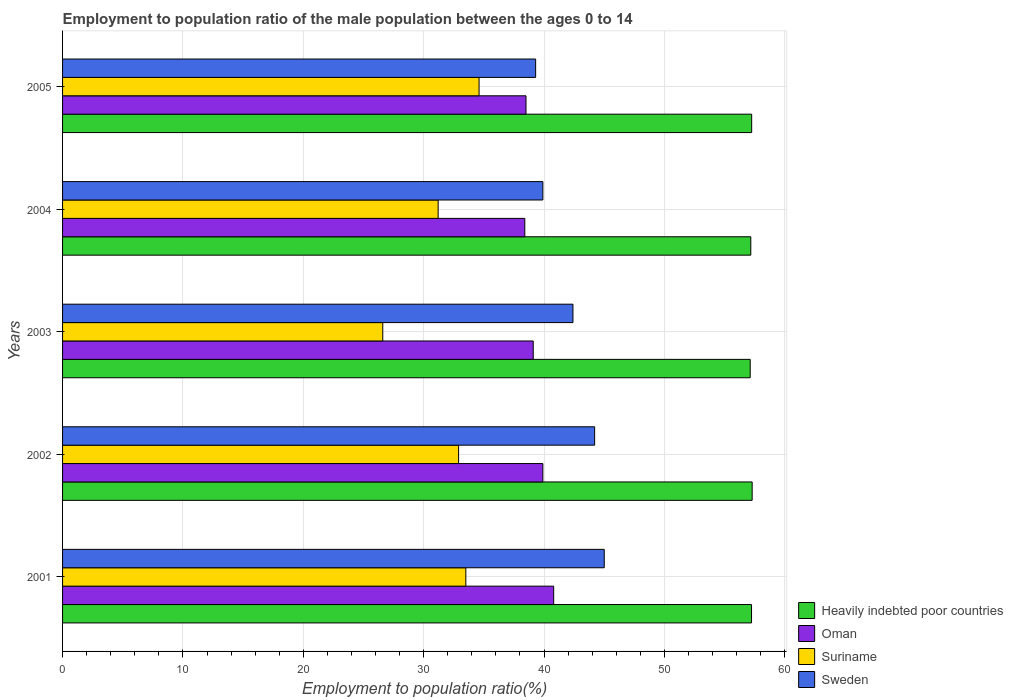How many groups of bars are there?
Keep it short and to the point. 5. Are the number of bars per tick equal to the number of legend labels?
Give a very brief answer. Yes. How many bars are there on the 4th tick from the top?
Make the answer very short. 4. How many bars are there on the 2nd tick from the bottom?
Provide a short and direct response. 4. What is the label of the 4th group of bars from the top?
Ensure brevity in your answer.  2002. What is the employment to population ratio in Sweden in 2004?
Your answer should be compact. 39.9. Across all years, what is the maximum employment to population ratio in Heavily indebted poor countries?
Your answer should be compact. 57.29. Across all years, what is the minimum employment to population ratio in Sweden?
Keep it short and to the point. 39.3. In which year was the employment to population ratio in Heavily indebted poor countries maximum?
Your answer should be compact. 2002. In which year was the employment to population ratio in Sweden minimum?
Make the answer very short. 2005. What is the total employment to population ratio in Sweden in the graph?
Provide a succinct answer. 210.8. What is the difference between the employment to population ratio in Suriname in 2003 and that in 2004?
Your answer should be compact. -4.6. What is the difference between the employment to population ratio in Oman in 2005 and the employment to population ratio in Heavily indebted poor countries in 2002?
Your answer should be very brief. -18.79. What is the average employment to population ratio in Oman per year?
Keep it short and to the point. 39.34. In the year 2003, what is the difference between the employment to population ratio in Heavily indebted poor countries and employment to population ratio in Oman?
Your response must be concise. 18.02. What is the ratio of the employment to population ratio in Suriname in 2003 to that in 2004?
Provide a succinct answer. 0.85. What is the difference between the highest and the second highest employment to population ratio in Sweden?
Keep it short and to the point. 0.8. What is the difference between the highest and the lowest employment to population ratio in Oman?
Provide a succinct answer. 2.4. In how many years, is the employment to population ratio in Sweden greater than the average employment to population ratio in Sweden taken over all years?
Offer a terse response. 3. Is the sum of the employment to population ratio in Suriname in 2004 and 2005 greater than the maximum employment to population ratio in Heavily indebted poor countries across all years?
Your answer should be very brief. Yes. Is it the case that in every year, the sum of the employment to population ratio in Suriname and employment to population ratio in Oman is greater than the sum of employment to population ratio in Sweden and employment to population ratio in Heavily indebted poor countries?
Make the answer very short. No. What does the 2nd bar from the top in 2002 represents?
Your answer should be very brief. Suriname. How many bars are there?
Give a very brief answer. 20. Are all the bars in the graph horizontal?
Your answer should be compact. Yes. What is the difference between two consecutive major ticks on the X-axis?
Your answer should be compact. 10. Are the values on the major ticks of X-axis written in scientific E-notation?
Your answer should be compact. No. Does the graph contain any zero values?
Your response must be concise. No. Where does the legend appear in the graph?
Provide a short and direct response. Bottom right. What is the title of the graph?
Your answer should be very brief. Employment to population ratio of the male population between the ages 0 to 14. Does "Guyana" appear as one of the legend labels in the graph?
Provide a succinct answer. No. What is the Employment to population ratio(%) of Heavily indebted poor countries in 2001?
Ensure brevity in your answer.  57.24. What is the Employment to population ratio(%) in Oman in 2001?
Your response must be concise. 40.8. What is the Employment to population ratio(%) of Suriname in 2001?
Keep it short and to the point. 33.5. What is the Employment to population ratio(%) of Sweden in 2001?
Ensure brevity in your answer.  45. What is the Employment to population ratio(%) of Heavily indebted poor countries in 2002?
Offer a terse response. 57.29. What is the Employment to population ratio(%) of Oman in 2002?
Your answer should be very brief. 39.9. What is the Employment to population ratio(%) in Suriname in 2002?
Offer a very short reply. 32.9. What is the Employment to population ratio(%) in Sweden in 2002?
Your response must be concise. 44.2. What is the Employment to population ratio(%) of Heavily indebted poor countries in 2003?
Provide a short and direct response. 57.12. What is the Employment to population ratio(%) of Oman in 2003?
Keep it short and to the point. 39.1. What is the Employment to population ratio(%) in Suriname in 2003?
Keep it short and to the point. 26.6. What is the Employment to population ratio(%) of Sweden in 2003?
Your response must be concise. 42.4. What is the Employment to population ratio(%) in Heavily indebted poor countries in 2004?
Ensure brevity in your answer.  57.17. What is the Employment to population ratio(%) of Oman in 2004?
Your answer should be very brief. 38.4. What is the Employment to population ratio(%) in Suriname in 2004?
Your answer should be very brief. 31.2. What is the Employment to population ratio(%) in Sweden in 2004?
Give a very brief answer. 39.9. What is the Employment to population ratio(%) of Heavily indebted poor countries in 2005?
Provide a succinct answer. 57.25. What is the Employment to population ratio(%) in Oman in 2005?
Give a very brief answer. 38.5. What is the Employment to population ratio(%) in Suriname in 2005?
Give a very brief answer. 34.6. What is the Employment to population ratio(%) of Sweden in 2005?
Keep it short and to the point. 39.3. Across all years, what is the maximum Employment to population ratio(%) of Heavily indebted poor countries?
Make the answer very short. 57.29. Across all years, what is the maximum Employment to population ratio(%) of Oman?
Your answer should be very brief. 40.8. Across all years, what is the maximum Employment to population ratio(%) in Suriname?
Your response must be concise. 34.6. Across all years, what is the maximum Employment to population ratio(%) in Sweden?
Your response must be concise. 45. Across all years, what is the minimum Employment to population ratio(%) of Heavily indebted poor countries?
Ensure brevity in your answer.  57.12. Across all years, what is the minimum Employment to population ratio(%) of Oman?
Offer a very short reply. 38.4. Across all years, what is the minimum Employment to population ratio(%) of Suriname?
Your answer should be very brief. 26.6. Across all years, what is the minimum Employment to population ratio(%) of Sweden?
Provide a short and direct response. 39.3. What is the total Employment to population ratio(%) of Heavily indebted poor countries in the graph?
Provide a succinct answer. 286.07. What is the total Employment to population ratio(%) in Oman in the graph?
Ensure brevity in your answer.  196.7. What is the total Employment to population ratio(%) in Suriname in the graph?
Your answer should be very brief. 158.8. What is the total Employment to population ratio(%) in Sweden in the graph?
Provide a short and direct response. 210.8. What is the difference between the Employment to population ratio(%) of Heavily indebted poor countries in 2001 and that in 2002?
Provide a succinct answer. -0.05. What is the difference between the Employment to population ratio(%) in Oman in 2001 and that in 2002?
Give a very brief answer. 0.9. What is the difference between the Employment to population ratio(%) in Suriname in 2001 and that in 2002?
Keep it short and to the point. 0.6. What is the difference between the Employment to population ratio(%) of Heavily indebted poor countries in 2001 and that in 2003?
Your answer should be compact. 0.11. What is the difference between the Employment to population ratio(%) in Oman in 2001 and that in 2003?
Your answer should be very brief. 1.7. What is the difference between the Employment to population ratio(%) of Suriname in 2001 and that in 2003?
Your answer should be very brief. 6.9. What is the difference between the Employment to population ratio(%) in Sweden in 2001 and that in 2003?
Keep it short and to the point. 2.6. What is the difference between the Employment to population ratio(%) in Heavily indebted poor countries in 2001 and that in 2004?
Provide a short and direct response. 0.06. What is the difference between the Employment to population ratio(%) in Oman in 2001 and that in 2004?
Ensure brevity in your answer.  2.4. What is the difference between the Employment to population ratio(%) in Sweden in 2001 and that in 2004?
Ensure brevity in your answer.  5.1. What is the difference between the Employment to population ratio(%) of Heavily indebted poor countries in 2001 and that in 2005?
Ensure brevity in your answer.  -0.01. What is the difference between the Employment to population ratio(%) of Oman in 2001 and that in 2005?
Offer a very short reply. 2.3. What is the difference between the Employment to population ratio(%) in Sweden in 2001 and that in 2005?
Your answer should be very brief. 5.7. What is the difference between the Employment to population ratio(%) of Heavily indebted poor countries in 2002 and that in 2003?
Your answer should be very brief. 0.16. What is the difference between the Employment to population ratio(%) in Oman in 2002 and that in 2003?
Make the answer very short. 0.8. What is the difference between the Employment to population ratio(%) of Heavily indebted poor countries in 2002 and that in 2004?
Provide a short and direct response. 0.11. What is the difference between the Employment to population ratio(%) in Sweden in 2002 and that in 2004?
Offer a very short reply. 4.3. What is the difference between the Employment to population ratio(%) of Heavily indebted poor countries in 2002 and that in 2005?
Give a very brief answer. 0.04. What is the difference between the Employment to population ratio(%) in Suriname in 2002 and that in 2005?
Provide a succinct answer. -1.7. What is the difference between the Employment to population ratio(%) of Heavily indebted poor countries in 2003 and that in 2004?
Ensure brevity in your answer.  -0.05. What is the difference between the Employment to population ratio(%) in Oman in 2003 and that in 2004?
Keep it short and to the point. 0.7. What is the difference between the Employment to population ratio(%) in Heavily indebted poor countries in 2003 and that in 2005?
Offer a very short reply. -0.12. What is the difference between the Employment to population ratio(%) in Oman in 2003 and that in 2005?
Offer a terse response. 0.6. What is the difference between the Employment to population ratio(%) in Suriname in 2003 and that in 2005?
Provide a succinct answer. -8. What is the difference between the Employment to population ratio(%) in Sweden in 2003 and that in 2005?
Your answer should be very brief. 3.1. What is the difference between the Employment to population ratio(%) of Heavily indebted poor countries in 2004 and that in 2005?
Make the answer very short. -0.07. What is the difference between the Employment to population ratio(%) of Oman in 2004 and that in 2005?
Keep it short and to the point. -0.1. What is the difference between the Employment to population ratio(%) of Suriname in 2004 and that in 2005?
Your answer should be very brief. -3.4. What is the difference between the Employment to population ratio(%) of Heavily indebted poor countries in 2001 and the Employment to population ratio(%) of Oman in 2002?
Provide a succinct answer. 17.34. What is the difference between the Employment to population ratio(%) of Heavily indebted poor countries in 2001 and the Employment to population ratio(%) of Suriname in 2002?
Your answer should be compact. 24.34. What is the difference between the Employment to population ratio(%) of Heavily indebted poor countries in 2001 and the Employment to population ratio(%) of Sweden in 2002?
Ensure brevity in your answer.  13.04. What is the difference between the Employment to population ratio(%) in Oman in 2001 and the Employment to population ratio(%) in Suriname in 2002?
Your answer should be compact. 7.9. What is the difference between the Employment to population ratio(%) in Oman in 2001 and the Employment to population ratio(%) in Sweden in 2002?
Make the answer very short. -3.4. What is the difference between the Employment to population ratio(%) in Heavily indebted poor countries in 2001 and the Employment to population ratio(%) in Oman in 2003?
Provide a succinct answer. 18.14. What is the difference between the Employment to population ratio(%) of Heavily indebted poor countries in 2001 and the Employment to population ratio(%) of Suriname in 2003?
Make the answer very short. 30.64. What is the difference between the Employment to population ratio(%) of Heavily indebted poor countries in 2001 and the Employment to population ratio(%) of Sweden in 2003?
Provide a short and direct response. 14.84. What is the difference between the Employment to population ratio(%) of Suriname in 2001 and the Employment to population ratio(%) of Sweden in 2003?
Your response must be concise. -8.9. What is the difference between the Employment to population ratio(%) in Heavily indebted poor countries in 2001 and the Employment to population ratio(%) in Oman in 2004?
Ensure brevity in your answer.  18.84. What is the difference between the Employment to population ratio(%) of Heavily indebted poor countries in 2001 and the Employment to population ratio(%) of Suriname in 2004?
Give a very brief answer. 26.04. What is the difference between the Employment to population ratio(%) in Heavily indebted poor countries in 2001 and the Employment to population ratio(%) in Sweden in 2004?
Ensure brevity in your answer.  17.34. What is the difference between the Employment to population ratio(%) in Oman in 2001 and the Employment to population ratio(%) in Suriname in 2004?
Give a very brief answer. 9.6. What is the difference between the Employment to population ratio(%) in Suriname in 2001 and the Employment to population ratio(%) in Sweden in 2004?
Ensure brevity in your answer.  -6.4. What is the difference between the Employment to population ratio(%) in Heavily indebted poor countries in 2001 and the Employment to population ratio(%) in Oman in 2005?
Your answer should be very brief. 18.74. What is the difference between the Employment to population ratio(%) in Heavily indebted poor countries in 2001 and the Employment to population ratio(%) in Suriname in 2005?
Your response must be concise. 22.64. What is the difference between the Employment to population ratio(%) of Heavily indebted poor countries in 2001 and the Employment to population ratio(%) of Sweden in 2005?
Provide a short and direct response. 17.94. What is the difference between the Employment to population ratio(%) in Suriname in 2001 and the Employment to population ratio(%) in Sweden in 2005?
Offer a very short reply. -5.8. What is the difference between the Employment to population ratio(%) of Heavily indebted poor countries in 2002 and the Employment to population ratio(%) of Oman in 2003?
Give a very brief answer. 18.19. What is the difference between the Employment to population ratio(%) in Heavily indebted poor countries in 2002 and the Employment to population ratio(%) in Suriname in 2003?
Keep it short and to the point. 30.69. What is the difference between the Employment to population ratio(%) in Heavily indebted poor countries in 2002 and the Employment to population ratio(%) in Sweden in 2003?
Provide a succinct answer. 14.89. What is the difference between the Employment to population ratio(%) in Oman in 2002 and the Employment to population ratio(%) in Suriname in 2003?
Offer a very short reply. 13.3. What is the difference between the Employment to population ratio(%) of Suriname in 2002 and the Employment to population ratio(%) of Sweden in 2003?
Keep it short and to the point. -9.5. What is the difference between the Employment to population ratio(%) in Heavily indebted poor countries in 2002 and the Employment to population ratio(%) in Oman in 2004?
Ensure brevity in your answer.  18.89. What is the difference between the Employment to population ratio(%) of Heavily indebted poor countries in 2002 and the Employment to population ratio(%) of Suriname in 2004?
Your response must be concise. 26.09. What is the difference between the Employment to population ratio(%) in Heavily indebted poor countries in 2002 and the Employment to population ratio(%) in Sweden in 2004?
Keep it short and to the point. 17.39. What is the difference between the Employment to population ratio(%) of Oman in 2002 and the Employment to population ratio(%) of Suriname in 2004?
Offer a terse response. 8.7. What is the difference between the Employment to population ratio(%) of Oman in 2002 and the Employment to population ratio(%) of Sweden in 2004?
Ensure brevity in your answer.  0. What is the difference between the Employment to population ratio(%) in Heavily indebted poor countries in 2002 and the Employment to population ratio(%) in Oman in 2005?
Your answer should be very brief. 18.79. What is the difference between the Employment to population ratio(%) of Heavily indebted poor countries in 2002 and the Employment to population ratio(%) of Suriname in 2005?
Offer a terse response. 22.69. What is the difference between the Employment to population ratio(%) in Heavily indebted poor countries in 2002 and the Employment to population ratio(%) in Sweden in 2005?
Give a very brief answer. 17.99. What is the difference between the Employment to population ratio(%) of Oman in 2002 and the Employment to population ratio(%) of Suriname in 2005?
Provide a succinct answer. 5.3. What is the difference between the Employment to population ratio(%) of Heavily indebted poor countries in 2003 and the Employment to population ratio(%) of Oman in 2004?
Keep it short and to the point. 18.72. What is the difference between the Employment to population ratio(%) in Heavily indebted poor countries in 2003 and the Employment to population ratio(%) in Suriname in 2004?
Your answer should be compact. 25.92. What is the difference between the Employment to population ratio(%) in Heavily indebted poor countries in 2003 and the Employment to population ratio(%) in Sweden in 2004?
Give a very brief answer. 17.22. What is the difference between the Employment to population ratio(%) of Oman in 2003 and the Employment to population ratio(%) of Suriname in 2004?
Provide a succinct answer. 7.9. What is the difference between the Employment to population ratio(%) of Oman in 2003 and the Employment to population ratio(%) of Sweden in 2004?
Ensure brevity in your answer.  -0.8. What is the difference between the Employment to population ratio(%) of Suriname in 2003 and the Employment to population ratio(%) of Sweden in 2004?
Offer a very short reply. -13.3. What is the difference between the Employment to population ratio(%) of Heavily indebted poor countries in 2003 and the Employment to population ratio(%) of Oman in 2005?
Your response must be concise. 18.62. What is the difference between the Employment to population ratio(%) of Heavily indebted poor countries in 2003 and the Employment to population ratio(%) of Suriname in 2005?
Offer a terse response. 22.52. What is the difference between the Employment to population ratio(%) in Heavily indebted poor countries in 2003 and the Employment to population ratio(%) in Sweden in 2005?
Offer a very short reply. 17.82. What is the difference between the Employment to population ratio(%) in Oman in 2003 and the Employment to population ratio(%) in Suriname in 2005?
Your answer should be very brief. 4.5. What is the difference between the Employment to population ratio(%) in Oman in 2003 and the Employment to population ratio(%) in Sweden in 2005?
Offer a terse response. -0.2. What is the difference between the Employment to population ratio(%) of Suriname in 2003 and the Employment to population ratio(%) of Sweden in 2005?
Make the answer very short. -12.7. What is the difference between the Employment to population ratio(%) in Heavily indebted poor countries in 2004 and the Employment to population ratio(%) in Oman in 2005?
Make the answer very short. 18.67. What is the difference between the Employment to population ratio(%) in Heavily indebted poor countries in 2004 and the Employment to population ratio(%) in Suriname in 2005?
Provide a succinct answer. 22.57. What is the difference between the Employment to population ratio(%) of Heavily indebted poor countries in 2004 and the Employment to population ratio(%) of Sweden in 2005?
Offer a terse response. 17.87. What is the difference between the Employment to population ratio(%) of Oman in 2004 and the Employment to population ratio(%) of Sweden in 2005?
Make the answer very short. -0.9. What is the difference between the Employment to population ratio(%) of Suriname in 2004 and the Employment to population ratio(%) of Sweden in 2005?
Ensure brevity in your answer.  -8.1. What is the average Employment to population ratio(%) in Heavily indebted poor countries per year?
Offer a very short reply. 57.21. What is the average Employment to population ratio(%) of Oman per year?
Your response must be concise. 39.34. What is the average Employment to population ratio(%) of Suriname per year?
Offer a very short reply. 31.76. What is the average Employment to population ratio(%) of Sweden per year?
Give a very brief answer. 42.16. In the year 2001, what is the difference between the Employment to population ratio(%) in Heavily indebted poor countries and Employment to population ratio(%) in Oman?
Offer a very short reply. 16.44. In the year 2001, what is the difference between the Employment to population ratio(%) of Heavily indebted poor countries and Employment to population ratio(%) of Suriname?
Your answer should be very brief. 23.74. In the year 2001, what is the difference between the Employment to population ratio(%) in Heavily indebted poor countries and Employment to population ratio(%) in Sweden?
Ensure brevity in your answer.  12.24. In the year 2002, what is the difference between the Employment to population ratio(%) of Heavily indebted poor countries and Employment to population ratio(%) of Oman?
Make the answer very short. 17.39. In the year 2002, what is the difference between the Employment to population ratio(%) of Heavily indebted poor countries and Employment to population ratio(%) of Suriname?
Offer a very short reply. 24.39. In the year 2002, what is the difference between the Employment to population ratio(%) of Heavily indebted poor countries and Employment to population ratio(%) of Sweden?
Make the answer very short. 13.09. In the year 2003, what is the difference between the Employment to population ratio(%) in Heavily indebted poor countries and Employment to population ratio(%) in Oman?
Provide a succinct answer. 18.02. In the year 2003, what is the difference between the Employment to population ratio(%) in Heavily indebted poor countries and Employment to population ratio(%) in Suriname?
Offer a terse response. 30.52. In the year 2003, what is the difference between the Employment to population ratio(%) in Heavily indebted poor countries and Employment to population ratio(%) in Sweden?
Ensure brevity in your answer.  14.72. In the year 2003, what is the difference between the Employment to population ratio(%) of Oman and Employment to population ratio(%) of Suriname?
Keep it short and to the point. 12.5. In the year 2003, what is the difference between the Employment to population ratio(%) in Suriname and Employment to population ratio(%) in Sweden?
Offer a terse response. -15.8. In the year 2004, what is the difference between the Employment to population ratio(%) in Heavily indebted poor countries and Employment to population ratio(%) in Oman?
Make the answer very short. 18.77. In the year 2004, what is the difference between the Employment to population ratio(%) in Heavily indebted poor countries and Employment to population ratio(%) in Suriname?
Offer a terse response. 25.97. In the year 2004, what is the difference between the Employment to population ratio(%) in Heavily indebted poor countries and Employment to population ratio(%) in Sweden?
Make the answer very short. 17.27. In the year 2004, what is the difference between the Employment to population ratio(%) in Oman and Employment to population ratio(%) in Suriname?
Keep it short and to the point. 7.2. In the year 2005, what is the difference between the Employment to population ratio(%) in Heavily indebted poor countries and Employment to population ratio(%) in Oman?
Make the answer very short. 18.75. In the year 2005, what is the difference between the Employment to population ratio(%) in Heavily indebted poor countries and Employment to population ratio(%) in Suriname?
Keep it short and to the point. 22.65. In the year 2005, what is the difference between the Employment to population ratio(%) in Heavily indebted poor countries and Employment to population ratio(%) in Sweden?
Your response must be concise. 17.95. In the year 2005, what is the difference between the Employment to population ratio(%) of Oman and Employment to population ratio(%) of Suriname?
Give a very brief answer. 3.9. In the year 2005, what is the difference between the Employment to population ratio(%) in Oman and Employment to population ratio(%) in Sweden?
Your answer should be very brief. -0.8. What is the ratio of the Employment to population ratio(%) of Oman in 2001 to that in 2002?
Your response must be concise. 1.02. What is the ratio of the Employment to population ratio(%) of Suriname in 2001 to that in 2002?
Your answer should be compact. 1.02. What is the ratio of the Employment to population ratio(%) in Sweden in 2001 to that in 2002?
Your response must be concise. 1.02. What is the ratio of the Employment to population ratio(%) of Oman in 2001 to that in 2003?
Offer a terse response. 1.04. What is the ratio of the Employment to population ratio(%) of Suriname in 2001 to that in 2003?
Provide a succinct answer. 1.26. What is the ratio of the Employment to population ratio(%) in Sweden in 2001 to that in 2003?
Provide a short and direct response. 1.06. What is the ratio of the Employment to population ratio(%) in Suriname in 2001 to that in 2004?
Provide a short and direct response. 1.07. What is the ratio of the Employment to population ratio(%) of Sweden in 2001 to that in 2004?
Your response must be concise. 1.13. What is the ratio of the Employment to population ratio(%) of Heavily indebted poor countries in 2001 to that in 2005?
Give a very brief answer. 1. What is the ratio of the Employment to population ratio(%) in Oman in 2001 to that in 2005?
Give a very brief answer. 1.06. What is the ratio of the Employment to population ratio(%) of Suriname in 2001 to that in 2005?
Provide a short and direct response. 0.97. What is the ratio of the Employment to population ratio(%) in Sweden in 2001 to that in 2005?
Your answer should be very brief. 1.15. What is the ratio of the Employment to population ratio(%) in Heavily indebted poor countries in 2002 to that in 2003?
Keep it short and to the point. 1. What is the ratio of the Employment to population ratio(%) in Oman in 2002 to that in 2003?
Make the answer very short. 1.02. What is the ratio of the Employment to population ratio(%) in Suriname in 2002 to that in 2003?
Provide a short and direct response. 1.24. What is the ratio of the Employment to population ratio(%) in Sweden in 2002 to that in 2003?
Your answer should be compact. 1.04. What is the ratio of the Employment to population ratio(%) in Heavily indebted poor countries in 2002 to that in 2004?
Your answer should be very brief. 1. What is the ratio of the Employment to population ratio(%) of Oman in 2002 to that in 2004?
Your response must be concise. 1.04. What is the ratio of the Employment to population ratio(%) in Suriname in 2002 to that in 2004?
Keep it short and to the point. 1.05. What is the ratio of the Employment to population ratio(%) in Sweden in 2002 to that in 2004?
Your answer should be very brief. 1.11. What is the ratio of the Employment to population ratio(%) in Oman in 2002 to that in 2005?
Your response must be concise. 1.04. What is the ratio of the Employment to population ratio(%) of Suriname in 2002 to that in 2005?
Your answer should be very brief. 0.95. What is the ratio of the Employment to population ratio(%) in Sweden in 2002 to that in 2005?
Keep it short and to the point. 1.12. What is the ratio of the Employment to population ratio(%) in Heavily indebted poor countries in 2003 to that in 2004?
Your answer should be very brief. 1. What is the ratio of the Employment to population ratio(%) of Oman in 2003 to that in 2004?
Your answer should be very brief. 1.02. What is the ratio of the Employment to population ratio(%) of Suriname in 2003 to that in 2004?
Your answer should be very brief. 0.85. What is the ratio of the Employment to population ratio(%) in Sweden in 2003 to that in 2004?
Offer a very short reply. 1.06. What is the ratio of the Employment to population ratio(%) in Oman in 2003 to that in 2005?
Offer a terse response. 1.02. What is the ratio of the Employment to population ratio(%) in Suriname in 2003 to that in 2005?
Provide a short and direct response. 0.77. What is the ratio of the Employment to population ratio(%) of Sweden in 2003 to that in 2005?
Keep it short and to the point. 1.08. What is the ratio of the Employment to population ratio(%) in Suriname in 2004 to that in 2005?
Your answer should be very brief. 0.9. What is the ratio of the Employment to population ratio(%) of Sweden in 2004 to that in 2005?
Offer a very short reply. 1.02. What is the difference between the highest and the second highest Employment to population ratio(%) of Heavily indebted poor countries?
Your answer should be compact. 0.04. What is the difference between the highest and the second highest Employment to population ratio(%) in Suriname?
Your response must be concise. 1.1. What is the difference between the highest and the lowest Employment to population ratio(%) of Heavily indebted poor countries?
Make the answer very short. 0.16. 